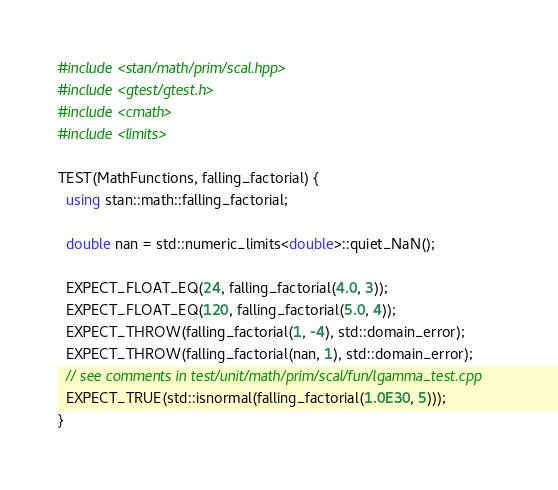Convert code to text. <code><loc_0><loc_0><loc_500><loc_500><_C++_>#include <stan/math/prim/scal.hpp>
#include <gtest/gtest.h>
#include <cmath>
#include <limits>

TEST(MathFunctions, falling_factorial) {
  using stan::math::falling_factorial;

  double nan = std::numeric_limits<double>::quiet_NaN();

  EXPECT_FLOAT_EQ(24, falling_factorial(4.0, 3));
  EXPECT_FLOAT_EQ(120, falling_factorial(5.0, 4));
  EXPECT_THROW(falling_factorial(1, -4), std::domain_error);
  EXPECT_THROW(falling_factorial(nan, 1), std::domain_error);
  // see comments in test/unit/math/prim/scal/fun/lgamma_test.cpp
  EXPECT_TRUE(std::isnormal(falling_factorial(1.0E30, 5)));
}
</code> 